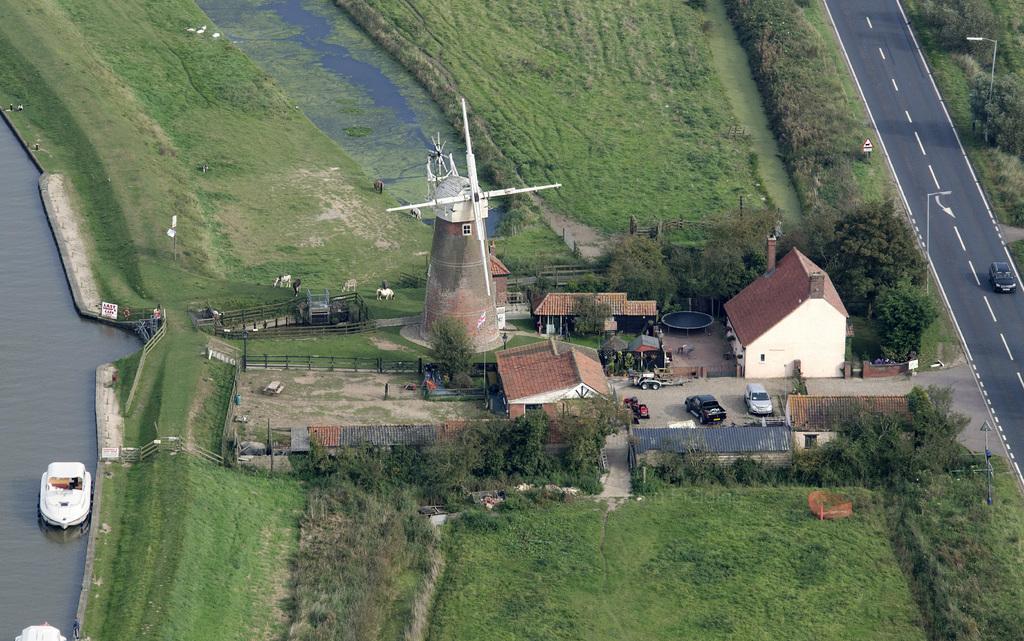Please provide a concise description of this image. This is the aerial view of an image. At the bottom, we see the grass and the trees, Beside that, we see the buildings and cars parked on the road. In the middle of the picture, we see the windmill and the fence. On the left side, we see the water and the boat sailing on the water. In the background, we see the grass and the water in the pond. On the right side, we see the car is moving on the road. Beside that, we see the streetlights and the trees. 